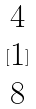<formula> <loc_0><loc_0><loc_500><loc_500>[ \begin{matrix} 4 \\ 1 \\ 8 \end{matrix} ]</formula> 